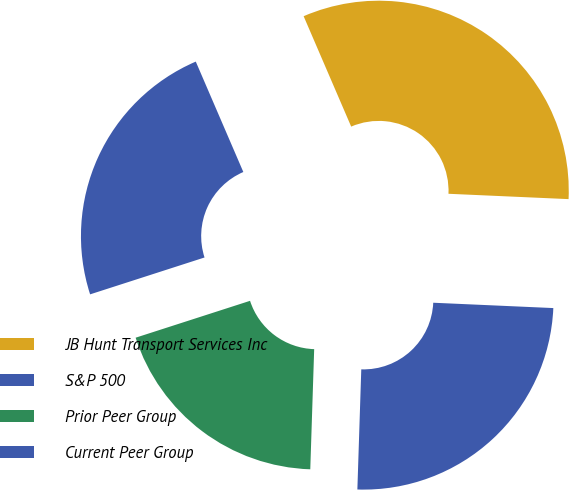Convert chart. <chart><loc_0><loc_0><loc_500><loc_500><pie_chart><fcel>JB Hunt Transport Services Inc<fcel>S&P 500<fcel>Prior Peer Group<fcel>Current Peer Group<nl><fcel>32.18%<fcel>23.49%<fcel>19.52%<fcel>24.81%<nl></chart> 